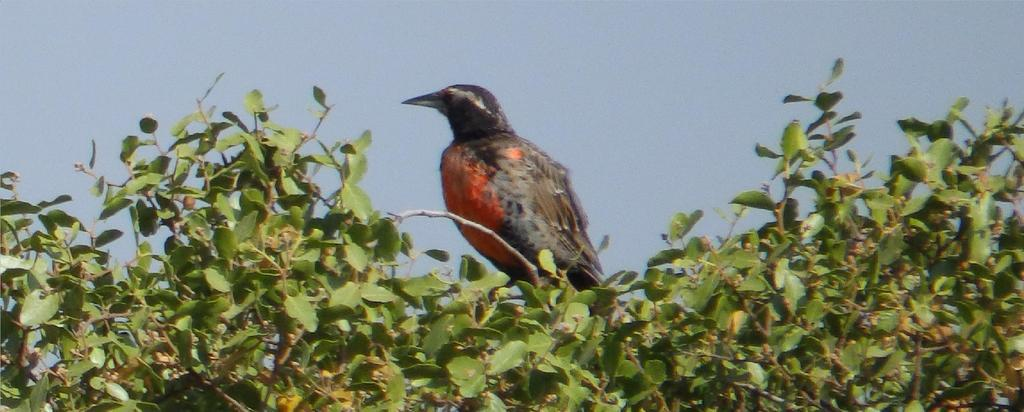What type of animal can be seen in the image? There is a bird in the image. Where is the bird located? The bird is on a tree. What is visible at the top of the image? The sky is visible at the top of the image. What type of apparatus is being used by the bird to fly in the image? There is no apparatus being used by the bird to fly in the image; birds naturally fly using their wings. Is it raining in the image? The provided facts do not mention anything about rain, so we cannot determine if it is raining in the image. 